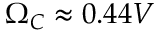<formula> <loc_0><loc_0><loc_500><loc_500>\Omega _ { C } \approx 0 . 4 4 V</formula> 